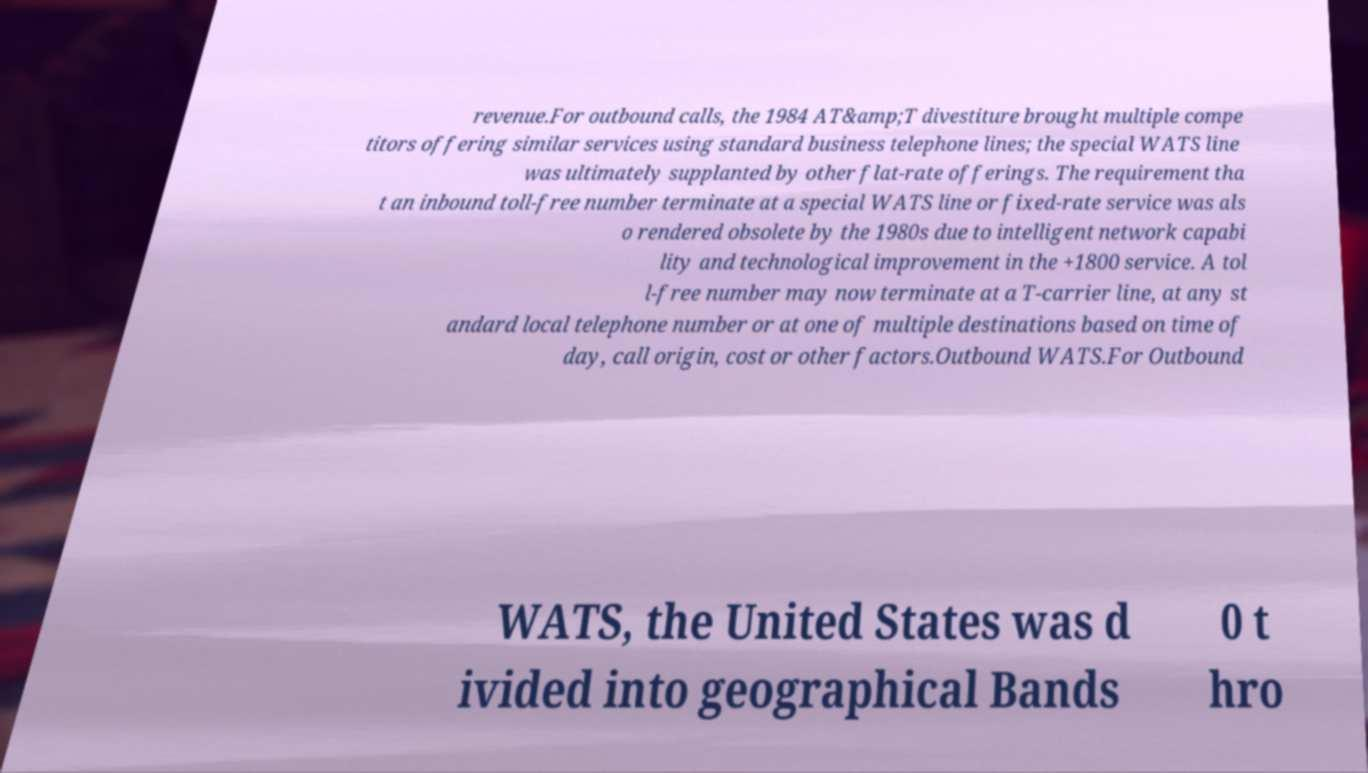I need the written content from this picture converted into text. Can you do that? revenue.For outbound calls, the 1984 AT&amp;T divestiture brought multiple compe titors offering similar services using standard business telephone lines; the special WATS line was ultimately supplanted by other flat-rate offerings. The requirement tha t an inbound toll-free number terminate at a special WATS line or fixed-rate service was als o rendered obsolete by the 1980s due to intelligent network capabi lity and technological improvement in the +1800 service. A tol l-free number may now terminate at a T-carrier line, at any st andard local telephone number or at one of multiple destinations based on time of day, call origin, cost or other factors.Outbound WATS.For Outbound WATS, the United States was d ivided into geographical Bands 0 t hro 